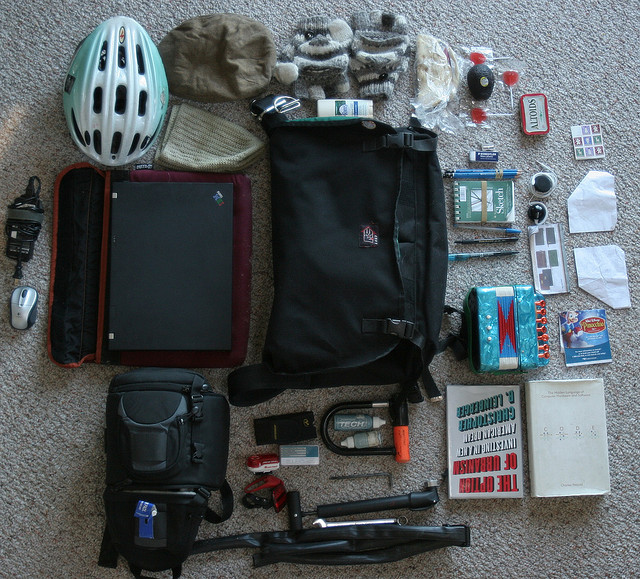Please transcribe the text information in this image. THE ROILDO 9 TCCH 10 